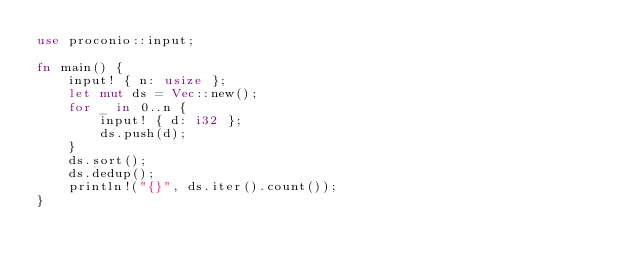<code> <loc_0><loc_0><loc_500><loc_500><_Rust_>use proconio::input;

fn main() {
    input! { n: usize };
    let mut ds = Vec::new();
    for _ in 0..n {
        input! { d: i32 };
        ds.push(d);
    }
    ds.sort();
    ds.dedup();
    println!("{}", ds.iter().count());
}
</code> 